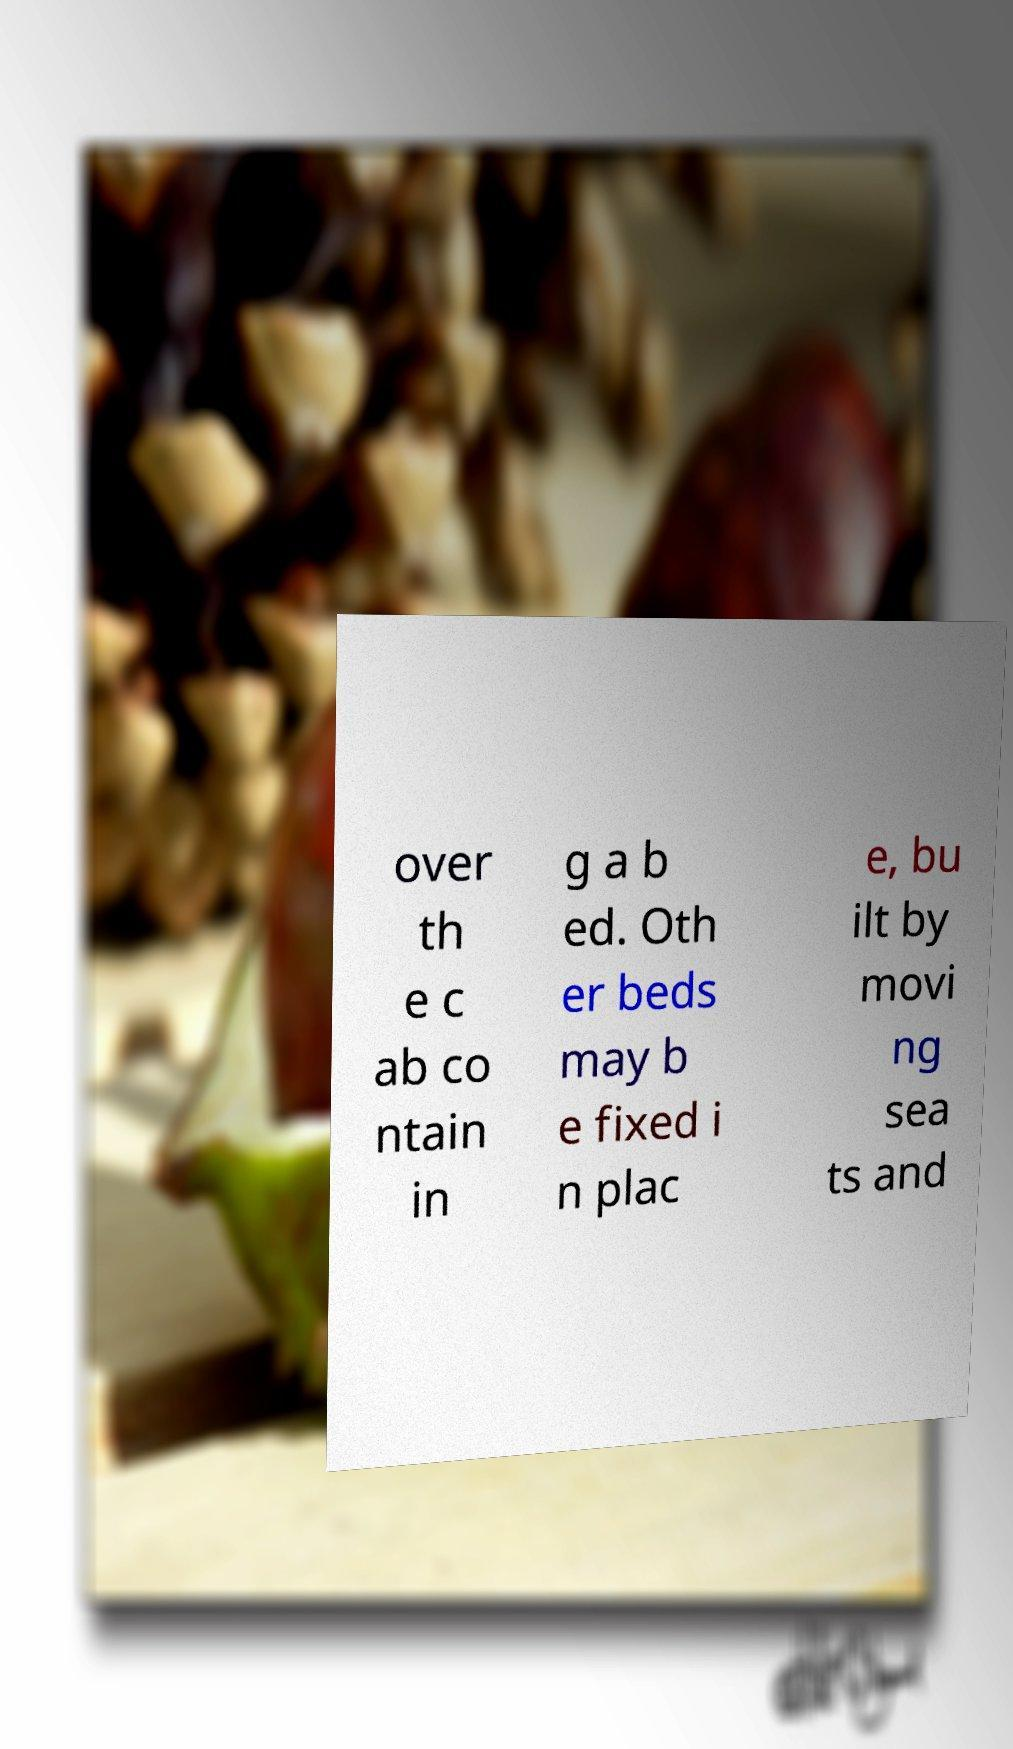Could you extract and type out the text from this image? over th e c ab co ntain in g a b ed. Oth er beds may b e fixed i n plac e, bu ilt by movi ng sea ts and 